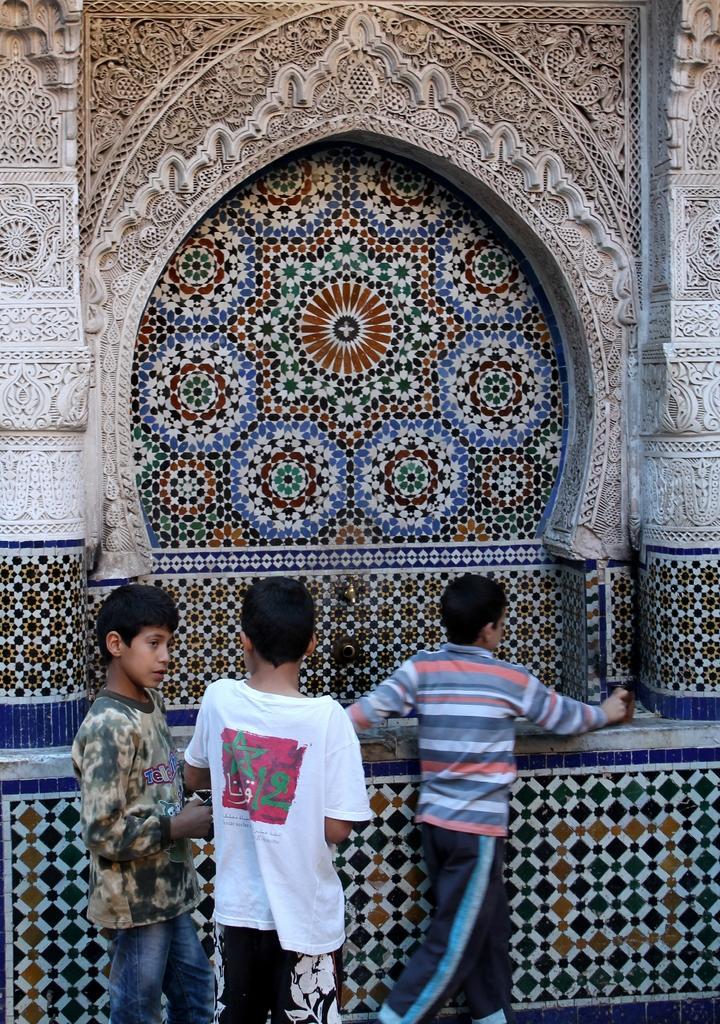Can you describe this image briefly? In this picture we can see three small boys, standing in the front. Behind there is a beautiful design arch and cladding tiles. 